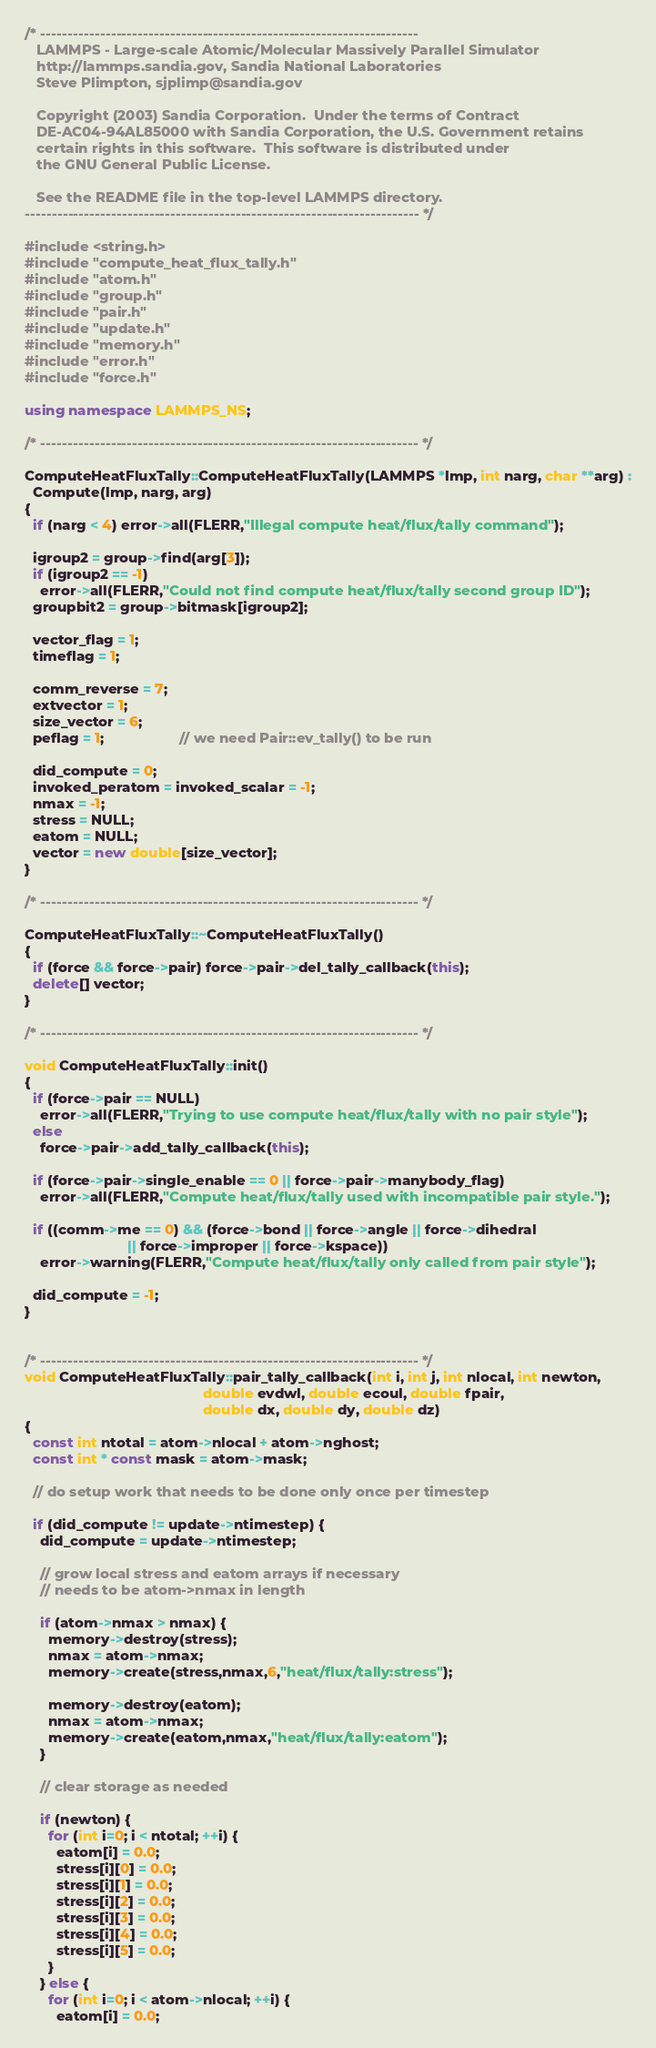Convert code to text. <code><loc_0><loc_0><loc_500><loc_500><_C++_>/* ----------------------------------------------------------------------
   LAMMPS - Large-scale Atomic/Molecular Massively Parallel Simulator
   http://lammps.sandia.gov, Sandia National Laboratories
   Steve Plimpton, sjplimp@sandia.gov

   Copyright (2003) Sandia Corporation.  Under the terms of Contract
   DE-AC04-94AL85000 with Sandia Corporation, the U.S. Government retains
   certain rights in this software.  This software is distributed under
   the GNU General Public License.

   See the README file in the top-level LAMMPS directory.
------------------------------------------------------------------------- */

#include <string.h>
#include "compute_heat_flux_tally.h"
#include "atom.h"
#include "group.h"
#include "pair.h"
#include "update.h"
#include "memory.h"
#include "error.h"
#include "force.h"

using namespace LAMMPS_NS;

/* ---------------------------------------------------------------------- */

ComputeHeatFluxTally::ComputeHeatFluxTally(LAMMPS *lmp, int narg, char **arg) :
  Compute(lmp, narg, arg)
{
  if (narg < 4) error->all(FLERR,"Illegal compute heat/flux/tally command");

  igroup2 = group->find(arg[3]);
  if (igroup2 == -1)
    error->all(FLERR,"Could not find compute heat/flux/tally second group ID");
  groupbit2 = group->bitmask[igroup2];

  vector_flag = 1;
  timeflag = 1;

  comm_reverse = 7;
  extvector = 1;
  size_vector = 6;
  peflag = 1;                   // we need Pair::ev_tally() to be run

  did_compute = 0;
  invoked_peratom = invoked_scalar = -1;
  nmax = -1;
  stress = NULL;
  eatom = NULL;
  vector = new double[size_vector];
}

/* ---------------------------------------------------------------------- */

ComputeHeatFluxTally::~ComputeHeatFluxTally()
{
  if (force && force->pair) force->pair->del_tally_callback(this);
  delete[] vector;
}

/* ---------------------------------------------------------------------- */

void ComputeHeatFluxTally::init()
{
  if (force->pair == NULL)
    error->all(FLERR,"Trying to use compute heat/flux/tally with no pair style");
  else
    force->pair->add_tally_callback(this);

  if (force->pair->single_enable == 0 || force->pair->manybody_flag)
    error->all(FLERR,"Compute heat/flux/tally used with incompatible pair style.");

  if ((comm->me == 0) && (force->bond || force->angle || force->dihedral
                          || force->improper || force->kspace))
    error->warning(FLERR,"Compute heat/flux/tally only called from pair style");

  did_compute = -1;
}


/* ---------------------------------------------------------------------- */
void ComputeHeatFluxTally::pair_tally_callback(int i, int j, int nlocal, int newton,
                                             double evdwl, double ecoul, double fpair,
                                             double dx, double dy, double dz)
{
  const int ntotal = atom->nlocal + atom->nghost;
  const int * const mask = atom->mask;

  // do setup work that needs to be done only once per timestep

  if (did_compute != update->ntimestep) {
    did_compute = update->ntimestep;

    // grow local stress and eatom arrays if necessary
    // needs to be atom->nmax in length

    if (atom->nmax > nmax) {
      memory->destroy(stress);
      nmax = atom->nmax;
      memory->create(stress,nmax,6,"heat/flux/tally:stress");

      memory->destroy(eatom);
      nmax = atom->nmax;
      memory->create(eatom,nmax,"heat/flux/tally:eatom");
    }

    // clear storage as needed

    if (newton) {
      for (int i=0; i < ntotal; ++i) {
        eatom[i] = 0.0;
        stress[i][0] = 0.0;
        stress[i][1] = 0.0;
        stress[i][2] = 0.0;
        stress[i][3] = 0.0;
        stress[i][4] = 0.0;
        stress[i][5] = 0.0;
      }
    } else {
      for (int i=0; i < atom->nlocal; ++i) {
        eatom[i] = 0.0;</code> 